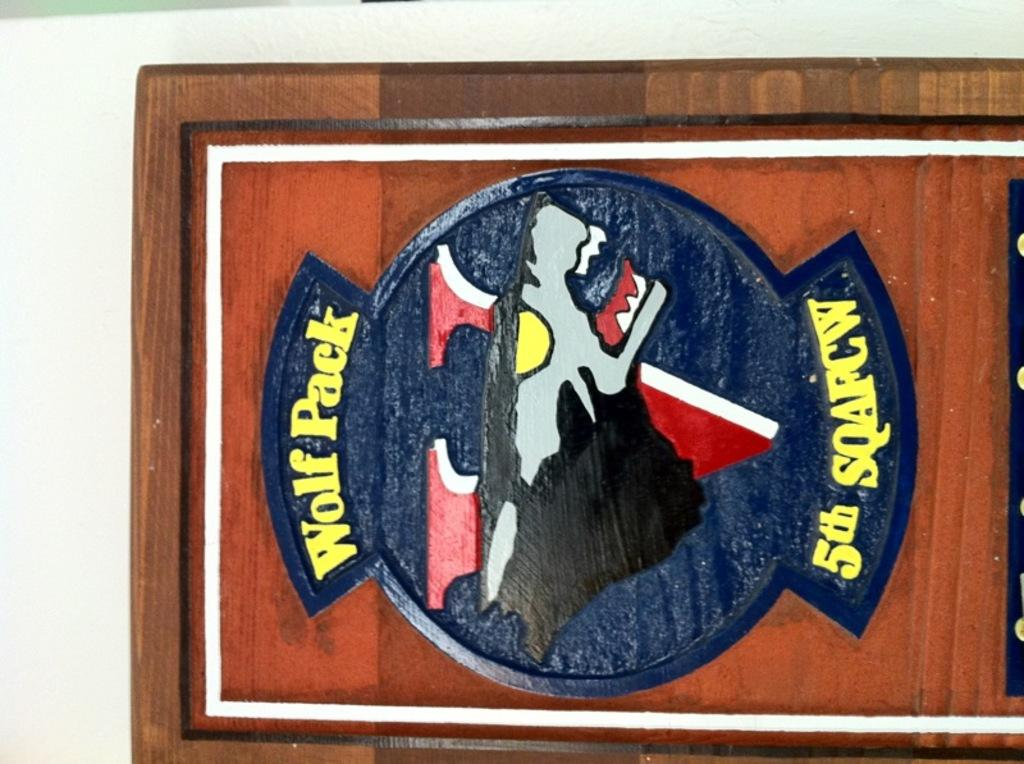<image>
Provide a brief description of the given image. a wooden carved sign of a wolf with words Wolf Pack 